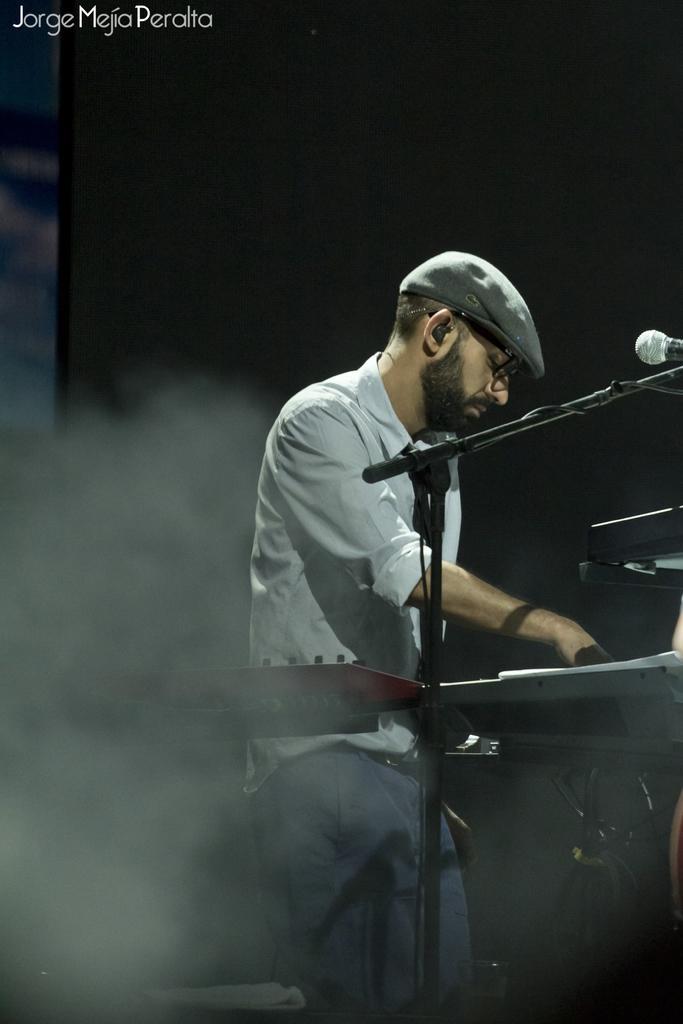How would you summarize this image in a sentence or two? In this image we can see there is a person playing musical instruments and there is a mic. On the top left side there is some text. 